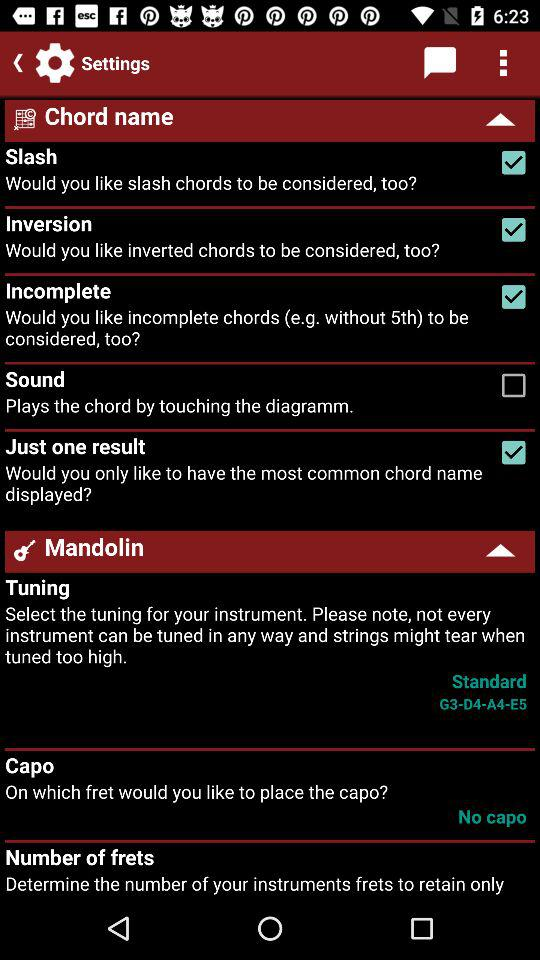What is the status of "Inversion"? The status is "on". 